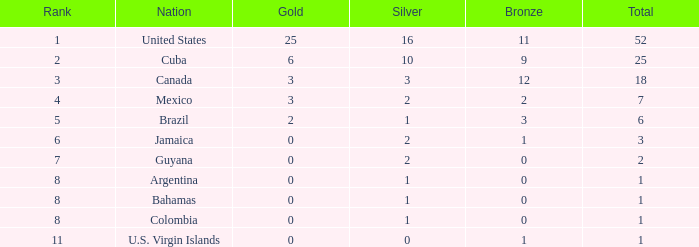What is the minimum number of silver medals a country ranked below 8 obtained? 0.0. 